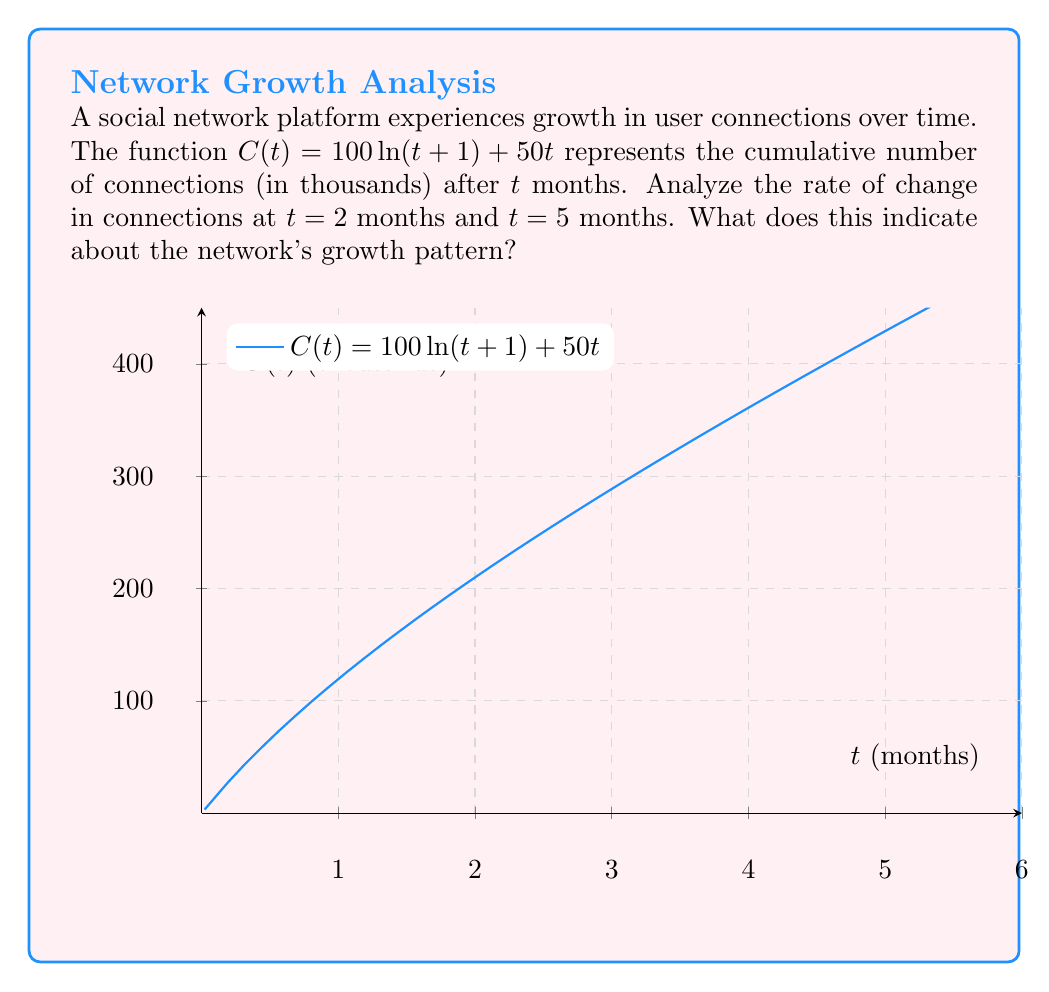Solve this math problem. To analyze the rate of change in connections, we need to find the derivative of $C(t)$ and evaluate it at the given time points.

Step 1: Find the derivative of $C(t)$
$$C(t) = 100\ln(t+1) + 50t$$
$$C'(t) = \frac{100}{t+1} + 50$$

Step 2: Evaluate $C'(t)$ at $t = 2$ and $t = 5$

For $t = 2$:
$$C'(2) = \frac{100}{2+1} + 50 = \frac{100}{3} + 50 \approx 83.33$$

For $t = 5$:
$$C'(5) = \frac{100}{5+1} + 50 = \frac{100}{6} + 50 \approx 66.67$$

Step 3: Interpret the results

The rate of change at $t = 2$ months is approximately 83,330 new connections per month, while at $t = 5$ months, it decreases to about 66,670 new connections per month.

This indicates that the network's growth rate is slowing down over time. The network is still growing (positive rate of change), but the pace of growth is decreasing as time progresses.

This pattern is typical for social networks, where initial growth is rapid due to network effects, but the rate of new connections tends to slow down as the network matures and approaches saturation.
Answer: The network's growth rate decreases from approximately 83,330 new connections per month at $t = 2$ to 66,670 at $t = 5$, indicating a slowing growth pattern. 